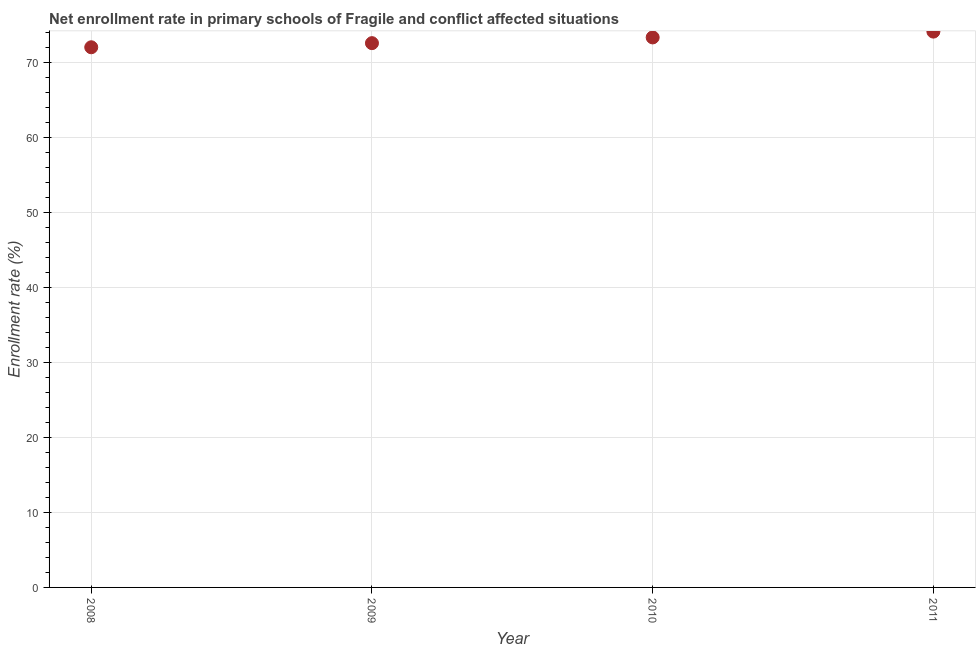What is the net enrollment rate in primary schools in 2011?
Make the answer very short. 74.13. Across all years, what is the maximum net enrollment rate in primary schools?
Ensure brevity in your answer.  74.13. Across all years, what is the minimum net enrollment rate in primary schools?
Make the answer very short. 72.04. In which year was the net enrollment rate in primary schools maximum?
Make the answer very short. 2011. What is the sum of the net enrollment rate in primary schools?
Your response must be concise. 292.11. What is the difference between the net enrollment rate in primary schools in 2009 and 2011?
Your answer should be very brief. -1.54. What is the average net enrollment rate in primary schools per year?
Ensure brevity in your answer.  73.03. What is the median net enrollment rate in primary schools?
Ensure brevity in your answer.  72.97. Do a majority of the years between 2011 and 2010 (inclusive) have net enrollment rate in primary schools greater than 22 %?
Provide a succinct answer. No. What is the ratio of the net enrollment rate in primary schools in 2009 to that in 2011?
Keep it short and to the point. 0.98. Is the net enrollment rate in primary schools in 2010 less than that in 2011?
Your answer should be very brief. Yes. Is the difference between the net enrollment rate in primary schools in 2008 and 2011 greater than the difference between any two years?
Your answer should be very brief. Yes. What is the difference between the highest and the second highest net enrollment rate in primary schools?
Your answer should be very brief. 0.78. What is the difference between the highest and the lowest net enrollment rate in primary schools?
Provide a succinct answer. 2.09. In how many years, is the net enrollment rate in primary schools greater than the average net enrollment rate in primary schools taken over all years?
Your answer should be compact. 2. What is the difference between two consecutive major ticks on the Y-axis?
Your response must be concise. 10. Does the graph contain any zero values?
Your answer should be very brief. No. What is the title of the graph?
Your answer should be very brief. Net enrollment rate in primary schools of Fragile and conflict affected situations. What is the label or title of the X-axis?
Keep it short and to the point. Year. What is the label or title of the Y-axis?
Your response must be concise. Enrollment rate (%). What is the Enrollment rate (%) in 2008?
Offer a very short reply. 72.04. What is the Enrollment rate (%) in 2009?
Make the answer very short. 72.59. What is the Enrollment rate (%) in 2010?
Offer a very short reply. 73.35. What is the Enrollment rate (%) in 2011?
Keep it short and to the point. 74.13. What is the difference between the Enrollment rate (%) in 2008 and 2009?
Provide a short and direct response. -0.55. What is the difference between the Enrollment rate (%) in 2008 and 2010?
Your answer should be very brief. -1.31. What is the difference between the Enrollment rate (%) in 2008 and 2011?
Your response must be concise. -2.09. What is the difference between the Enrollment rate (%) in 2009 and 2010?
Provide a short and direct response. -0.76. What is the difference between the Enrollment rate (%) in 2009 and 2011?
Your answer should be compact. -1.54. What is the difference between the Enrollment rate (%) in 2010 and 2011?
Offer a terse response. -0.78. What is the ratio of the Enrollment rate (%) in 2008 to that in 2010?
Offer a terse response. 0.98. What is the ratio of the Enrollment rate (%) in 2008 to that in 2011?
Give a very brief answer. 0.97. What is the ratio of the Enrollment rate (%) in 2009 to that in 2010?
Offer a very short reply. 0.99. What is the ratio of the Enrollment rate (%) in 2009 to that in 2011?
Make the answer very short. 0.98. What is the ratio of the Enrollment rate (%) in 2010 to that in 2011?
Make the answer very short. 0.99. 